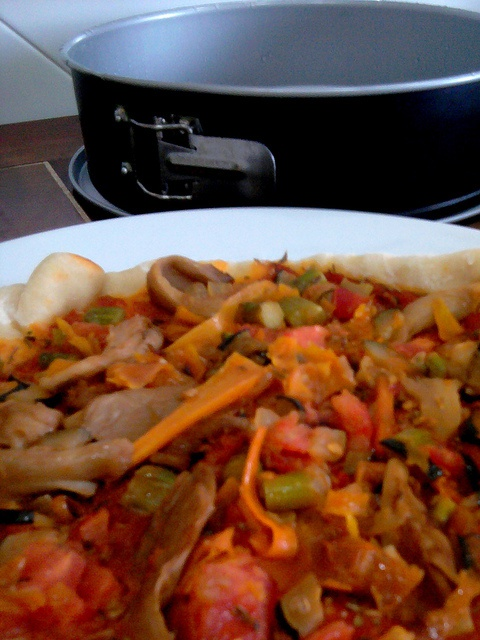Describe the objects in this image and their specific colors. I can see pizza in darkgray, maroon, and brown tones, bowl in darkgray, lavender, black, lightblue, and tan tones, carrot in darkgray, red, and maroon tones, carrot in darkgray, red, maroon, and orange tones, and carrot in darkgray, olive, maroon, and gray tones in this image. 